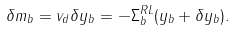Convert formula to latex. <formula><loc_0><loc_0><loc_500><loc_500>\delta m _ { b } = v _ { d } \delta y _ { b } = - \Sigma _ { b } ^ { R L } ( y _ { b } + \delta y _ { b } ) .</formula> 